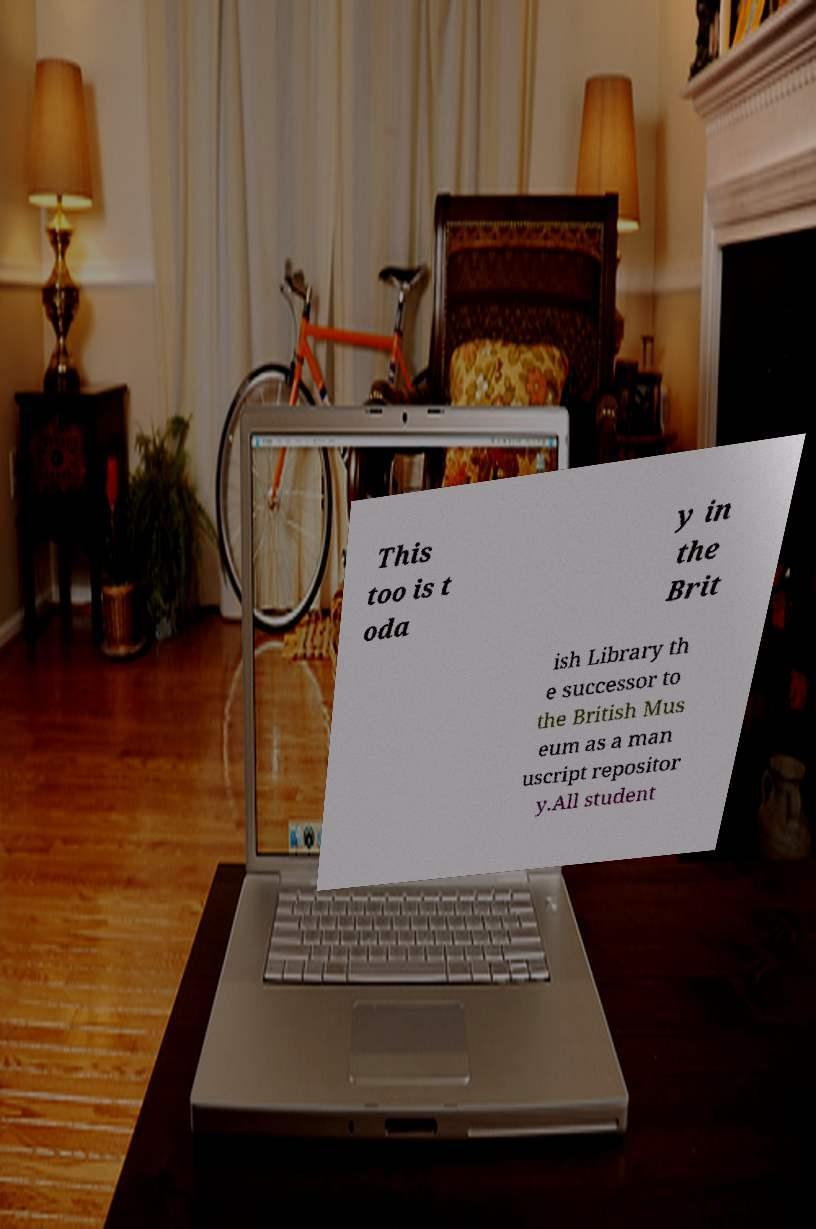There's text embedded in this image that I need extracted. Can you transcribe it verbatim? This too is t oda y in the Brit ish Library th e successor to the British Mus eum as a man uscript repositor y.All student 